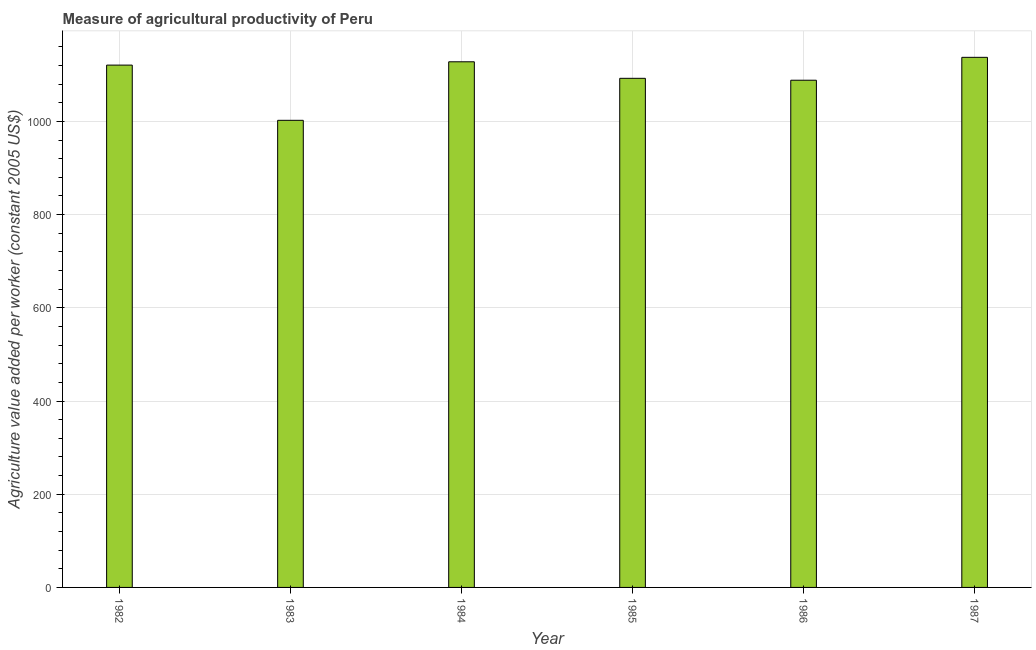Does the graph contain any zero values?
Offer a very short reply. No. What is the title of the graph?
Offer a terse response. Measure of agricultural productivity of Peru. What is the label or title of the Y-axis?
Make the answer very short. Agriculture value added per worker (constant 2005 US$). What is the agriculture value added per worker in 1983?
Give a very brief answer. 1002.32. Across all years, what is the maximum agriculture value added per worker?
Provide a short and direct response. 1137.48. Across all years, what is the minimum agriculture value added per worker?
Make the answer very short. 1002.32. In which year was the agriculture value added per worker minimum?
Provide a short and direct response. 1983. What is the sum of the agriculture value added per worker?
Provide a succinct answer. 6569.35. What is the difference between the agriculture value added per worker in 1984 and 1985?
Your response must be concise. 35.48. What is the average agriculture value added per worker per year?
Provide a short and direct response. 1094.89. What is the median agriculture value added per worker?
Your answer should be compact. 1106.63. What is the ratio of the agriculture value added per worker in 1983 to that in 1984?
Ensure brevity in your answer.  0.89. Is the agriculture value added per worker in 1984 less than that in 1985?
Provide a short and direct response. No. What is the difference between the highest and the second highest agriculture value added per worker?
Keep it short and to the point. 9.56. Is the sum of the agriculture value added per worker in 1983 and 1985 greater than the maximum agriculture value added per worker across all years?
Offer a very short reply. Yes. What is the difference between the highest and the lowest agriculture value added per worker?
Offer a very short reply. 135.16. In how many years, is the agriculture value added per worker greater than the average agriculture value added per worker taken over all years?
Ensure brevity in your answer.  3. Are all the bars in the graph horizontal?
Offer a very short reply. No. How many years are there in the graph?
Provide a short and direct response. 6. What is the Agriculture value added per worker (constant 2005 US$) in 1982?
Offer a very short reply. 1120.82. What is the Agriculture value added per worker (constant 2005 US$) in 1983?
Give a very brief answer. 1002.32. What is the Agriculture value added per worker (constant 2005 US$) in 1984?
Ensure brevity in your answer.  1127.92. What is the Agriculture value added per worker (constant 2005 US$) of 1985?
Offer a terse response. 1092.45. What is the Agriculture value added per worker (constant 2005 US$) of 1986?
Your response must be concise. 1088.36. What is the Agriculture value added per worker (constant 2005 US$) in 1987?
Your answer should be very brief. 1137.48. What is the difference between the Agriculture value added per worker (constant 2005 US$) in 1982 and 1983?
Your answer should be very brief. 118.49. What is the difference between the Agriculture value added per worker (constant 2005 US$) in 1982 and 1984?
Provide a short and direct response. -7.11. What is the difference between the Agriculture value added per worker (constant 2005 US$) in 1982 and 1985?
Keep it short and to the point. 28.37. What is the difference between the Agriculture value added per worker (constant 2005 US$) in 1982 and 1986?
Your answer should be compact. 32.45. What is the difference between the Agriculture value added per worker (constant 2005 US$) in 1982 and 1987?
Your answer should be very brief. -16.66. What is the difference between the Agriculture value added per worker (constant 2005 US$) in 1983 and 1984?
Your answer should be compact. -125.6. What is the difference between the Agriculture value added per worker (constant 2005 US$) in 1983 and 1985?
Give a very brief answer. -90.12. What is the difference between the Agriculture value added per worker (constant 2005 US$) in 1983 and 1986?
Your answer should be compact. -86.04. What is the difference between the Agriculture value added per worker (constant 2005 US$) in 1983 and 1987?
Give a very brief answer. -135.16. What is the difference between the Agriculture value added per worker (constant 2005 US$) in 1984 and 1985?
Your answer should be very brief. 35.48. What is the difference between the Agriculture value added per worker (constant 2005 US$) in 1984 and 1986?
Provide a short and direct response. 39.56. What is the difference between the Agriculture value added per worker (constant 2005 US$) in 1984 and 1987?
Offer a very short reply. -9.56. What is the difference between the Agriculture value added per worker (constant 2005 US$) in 1985 and 1986?
Make the answer very short. 4.08. What is the difference between the Agriculture value added per worker (constant 2005 US$) in 1985 and 1987?
Give a very brief answer. -45.03. What is the difference between the Agriculture value added per worker (constant 2005 US$) in 1986 and 1987?
Your response must be concise. -49.12. What is the ratio of the Agriculture value added per worker (constant 2005 US$) in 1982 to that in 1983?
Offer a very short reply. 1.12. What is the ratio of the Agriculture value added per worker (constant 2005 US$) in 1982 to that in 1984?
Offer a terse response. 0.99. What is the ratio of the Agriculture value added per worker (constant 2005 US$) in 1982 to that in 1985?
Make the answer very short. 1.03. What is the ratio of the Agriculture value added per worker (constant 2005 US$) in 1982 to that in 1987?
Your response must be concise. 0.98. What is the ratio of the Agriculture value added per worker (constant 2005 US$) in 1983 to that in 1984?
Keep it short and to the point. 0.89. What is the ratio of the Agriculture value added per worker (constant 2005 US$) in 1983 to that in 1985?
Your answer should be very brief. 0.92. What is the ratio of the Agriculture value added per worker (constant 2005 US$) in 1983 to that in 1986?
Your response must be concise. 0.92. What is the ratio of the Agriculture value added per worker (constant 2005 US$) in 1983 to that in 1987?
Offer a terse response. 0.88. What is the ratio of the Agriculture value added per worker (constant 2005 US$) in 1984 to that in 1985?
Ensure brevity in your answer.  1.03. What is the ratio of the Agriculture value added per worker (constant 2005 US$) in 1984 to that in 1986?
Ensure brevity in your answer.  1.04. What is the ratio of the Agriculture value added per worker (constant 2005 US$) in 1985 to that in 1987?
Your answer should be compact. 0.96. What is the ratio of the Agriculture value added per worker (constant 2005 US$) in 1986 to that in 1987?
Your answer should be compact. 0.96. 